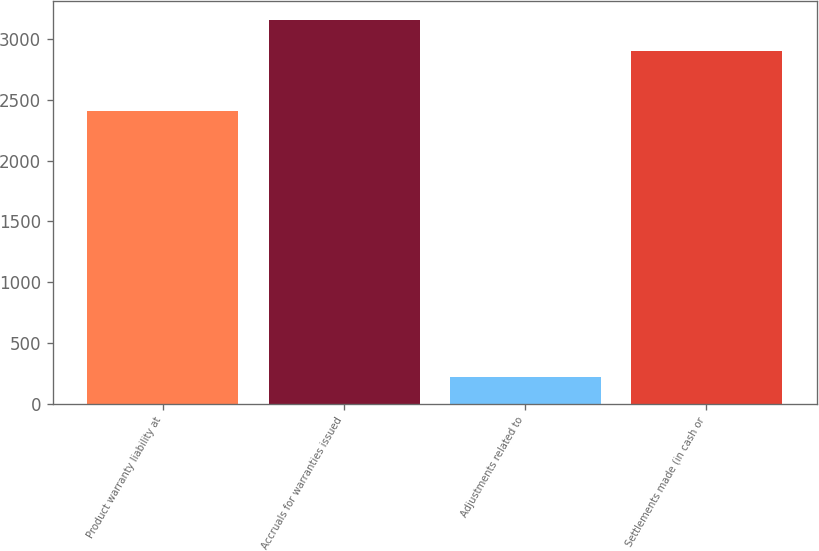Convert chart to OTSL. <chart><loc_0><loc_0><loc_500><loc_500><bar_chart><fcel>Product warranty liability at<fcel>Accruals for warranties issued<fcel>Adjustments related to<fcel>Settlements made (in cash or<nl><fcel>2409<fcel>3152.4<fcel>223<fcel>2904.6<nl></chart> 